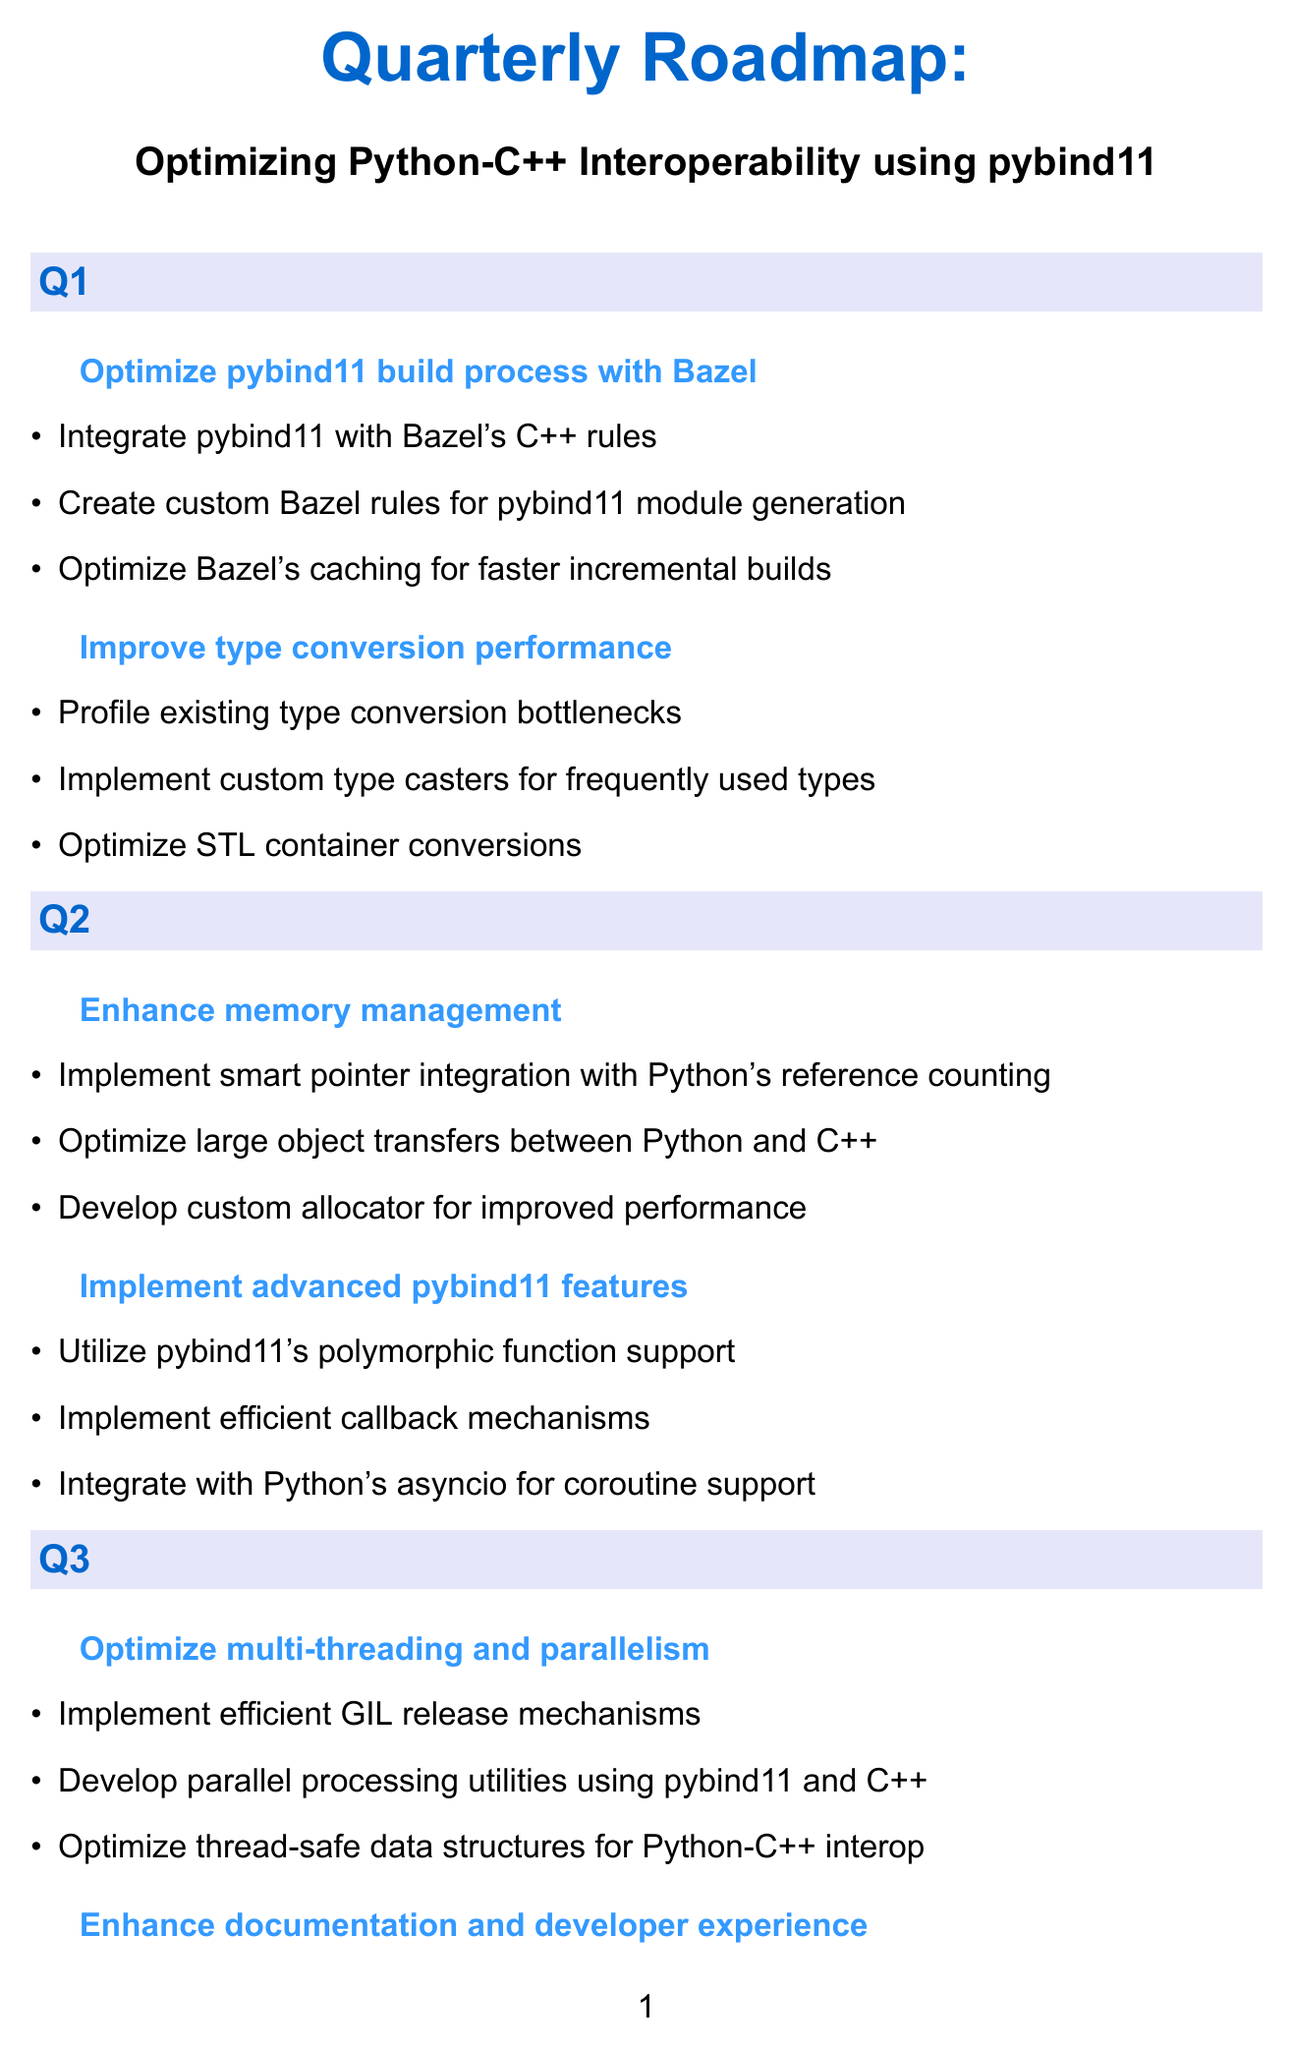What are the tasks for Q1 objective "Optimize pybind11 build process with Bazel"? The tasks for this objective include integrating pybind11 with Bazel's C++ rules, creating custom Bazel rules for pybind11 module generation, and optimizing Bazel's caching for faster incremental builds.
Answer: Integrate pybind11 with Bazel's C++ rules, Create custom Bazel rules for pybind11 module generation, Optimize Bazel's caching for faster incremental builds How many objectives are outlined for Q2? The document lists two objectives for Q2, focusing on memory management and advanced pybind11 features.
Answer: 2 What is the primary focus of the Q3 objective "Enhance documentation and developer experience"? This objective aims to improve the documentation and experience for developers working with pybind11, ensuring better support and guidance.
Answer: Enhance documentation and developer experience What task is part of optimizing memory management in Q2? The tasks under this objective include implementing smart pointer integration with Python's reference counting, optimizing large object transfers between Python and C++, and developing a custom allocator for improved performance.
Answer: Implement smart pointer integration with Python's reference counting What is the final objective set for Q4? The last objective mentioned for Q4 is "Advanced Bazel integration."
Answer: Advanced Bazel integration 